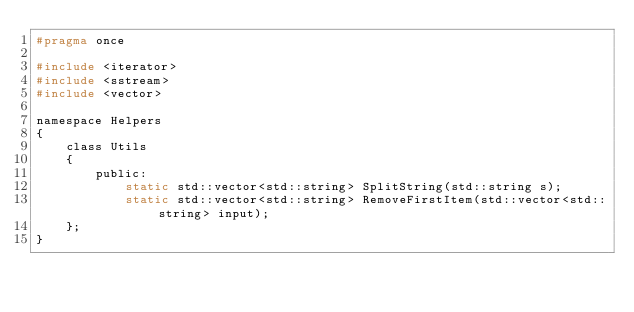Convert code to text. <code><loc_0><loc_0><loc_500><loc_500><_C_>#pragma once

#include <iterator>
#include <sstream>
#include <vector>

namespace Helpers
{
	class Utils
	{
		public:
			static std::vector<std::string> SplitString(std::string s);
			static std::vector<std::string> RemoveFirstItem(std::vector<std::string> input);
	};
}

</code> 